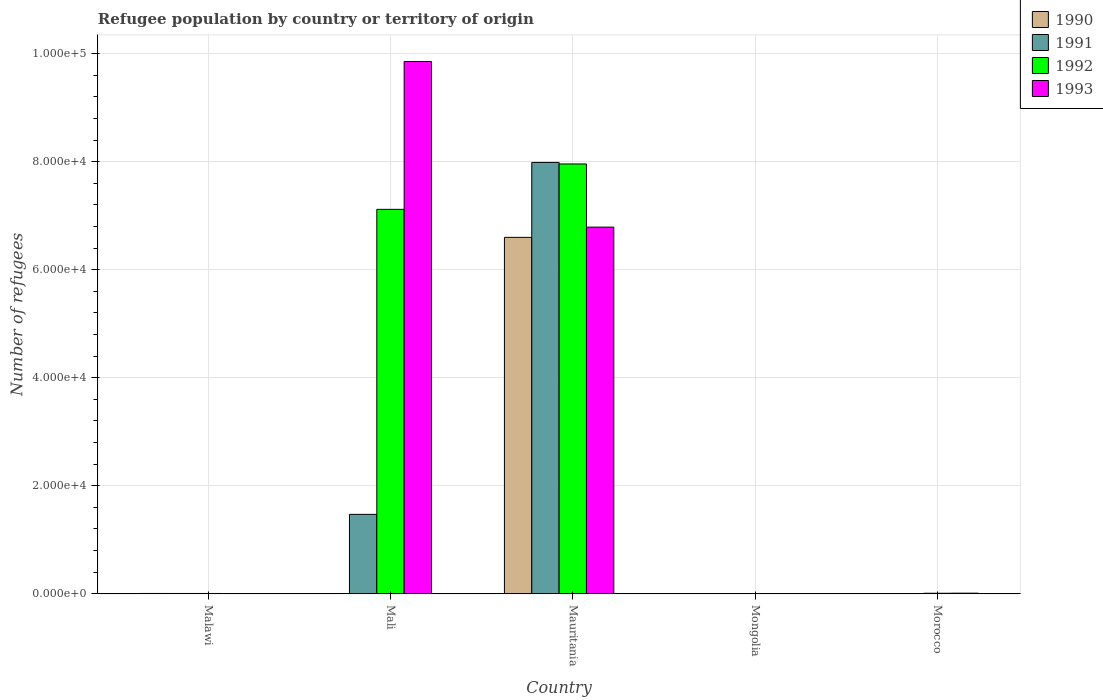How many different coloured bars are there?
Keep it short and to the point. 4. How many groups of bars are there?
Offer a terse response. 5. Are the number of bars per tick equal to the number of legend labels?
Ensure brevity in your answer.  Yes. How many bars are there on the 5th tick from the left?
Your response must be concise. 4. How many bars are there on the 1st tick from the right?
Your answer should be compact. 4. What is the label of the 2nd group of bars from the left?
Offer a terse response. Mali. What is the number of refugees in 1993 in Mongolia?
Ensure brevity in your answer.  1. Across all countries, what is the maximum number of refugees in 1992?
Provide a short and direct response. 7.96e+04. In which country was the number of refugees in 1990 maximum?
Give a very brief answer. Mauritania. In which country was the number of refugees in 1993 minimum?
Give a very brief answer. Mongolia. What is the total number of refugees in 1993 in the graph?
Provide a succinct answer. 1.67e+05. What is the difference between the number of refugees in 1992 in Malawi and that in Mali?
Keep it short and to the point. -7.11e+04. What is the difference between the number of refugees in 1992 in Mongolia and the number of refugees in 1993 in Malawi?
Offer a very short reply. -43. What is the average number of refugees in 1991 per country?
Ensure brevity in your answer.  1.89e+04. In how many countries, is the number of refugees in 1990 greater than 60000?
Your response must be concise. 1. What is the ratio of the number of refugees in 1990 in Malawi to that in Morocco?
Ensure brevity in your answer.  3.53. Is the number of refugees in 1991 in Mauritania less than that in Morocco?
Ensure brevity in your answer.  No. What is the difference between the highest and the second highest number of refugees in 1990?
Provide a succinct answer. -38. What is the difference between the highest and the lowest number of refugees in 1993?
Your response must be concise. 9.86e+04. Is the sum of the number of refugees in 1990 in Malawi and Morocco greater than the maximum number of refugees in 1992 across all countries?
Your answer should be compact. No. What does the 3rd bar from the right in Mongolia represents?
Keep it short and to the point. 1991. Is it the case that in every country, the sum of the number of refugees in 1993 and number of refugees in 1990 is greater than the number of refugees in 1991?
Offer a terse response. Yes. Are all the bars in the graph horizontal?
Provide a short and direct response. No. How many countries are there in the graph?
Your response must be concise. 5. Are the values on the major ticks of Y-axis written in scientific E-notation?
Give a very brief answer. Yes. Does the graph contain any zero values?
Provide a short and direct response. No. Does the graph contain grids?
Your answer should be very brief. Yes. How many legend labels are there?
Provide a short and direct response. 4. What is the title of the graph?
Your answer should be compact. Refugee population by country or territory of origin. What is the label or title of the Y-axis?
Your answer should be very brief. Number of refugees. What is the Number of refugees in 1990 in Malawi?
Your answer should be compact. 53. What is the Number of refugees of 1993 in Malawi?
Provide a short and direct response. 44. What is the Number of refugees in 1991 in Mali?
Ensure brevity in your answer.  1.47e+04. What is the Number of refugees in 1992 in Mali?
Offer a terse response. 7.12e+04. What is the Number of refugees in 1993 in Mali?
Your answer should be very brief. 9.86e+04. What is the Number of refugees of 1990 in Mauritania?
Your answer should be very brief. 6.60e+04. What is the Number of refugees in 1991 in Mauritania?
Make the answer very short. 7.99e+04. What is the Number of refugees of 1992 in Mauritania?
Give a very brief answer. 7.96e+04. What is the Number of refugees in 1993 in Mauritania?
Ensure brevity in your answer.  6.79e+04. What is the Number of refugees in 1990 in Mongolia?
Your answer should be very brief. 1. What is the Number of refugees in 1991 in Mongolia?
Your answer should be very brief. 1. What is the Number of refugees of 1992 in Mongolia?
Offer a very short reply. 1. What is the Number of refugees in 1993 in Mongolia?
Offer a terse response. 1. What is the Number of refugees in 1990 in Morocco?
Your answer should be very brief. 15. What is the Number of refugees of 1991 in Morocco?
Provide a short and direct response. 44. What is the Number of refugees in 1992 in Morocco?
Keep it short and to the point. 91. What is the Number of refugees in 1993 in Morocco?
Your response must be concise. 105. Across all countries, what is the maximum Number of refugees in 1990?
Your response must be concise. 6.60e+04. Across all countries, what is the maximum Number of refugees of 1991?
Offer a terse response. 7.99e+04. Across all countries, what is the maximum Number of refugees in 1992?
Your answer should be compact. 7.96e+04. Across all countries, what is the maximum Number of refugees of 1993?
Ensure brevity in your answer.  9.86e+04. Across all countries, what is the minimum Number of refugees of 1990?
Offer a very short reply. 1. Across all countries, what is the minimum Number of refugees of 1991?
Make the answer very short. 1. What is the total Number of refugees of 1990 in the graph?
Offer a very short reply. 6.61e+04. What is the total Number of refugees of 1991 in the graph?
Make the answer very short. 9.47e+04. What is the total Number of refugees of 1992 in the graph?
Your response must be concise. 1.51e+05. What is the total Number of refugees of 1993 in the graph?
Keep it short and to the point. 1.67e+05. What is the difference between the Number of refugees in 1990 in Malawi and that in Mali?
Your answer should be very brief. 52. What is the difference between the Number of refugees in 1991 in Malawi and that in Mali?
Your answer should be compact. -1.47e+04. What is the difference between the Number of refugees in 1992 in Malawi and that in Mali?
Ensure brevity in your answer.  -7.11e+04. What is the difference between the Number of refugees in 1993 in Malawi and that in Mali?
Offer a very short reply. -9.85e+04. What is the difference between the Number of refugees in 1990 in Malawi and that in Mauritania?
Provide a short and direct response. -6.59e+04. What is the difference between the Number of refugees in 1991 in Malawi and that in Mauritania?
Offer a very short reply. -7.98e+04. What is the difference between the Number of refugees of 1992 in Malawi and that in Mauritania?
Your answer should be compact. -7.95e+04. What is the difference between the Number of refugees of 1993 in Malawi and that in Mauritania?
Your response must be concise. -6.78e+04. What is the difference between the Number of refugees of 1990 in Malawi and that in Mongolia?
Provide a succinct answer. 52. What is the difference between the Number of refugees in 1990 in Malawi and that in Morocco?
Ensure brevity in your answer.  38. What is the difference between the Number of refugees in 1992 in Malawi and that in Morocco?
Make the answer very short. -41. What is the difference between the Number of refugees of 1993 in Malawi and that in Morocco?
Your answer should be very brief. -61. What is the difference between the Number of refugees of 1990 in Mali and that in Mauritania?
Your answer should be compact. -6.60e+04. What is the difference between the Number of refugees in 1991 in Mali and that in Mauritania?
Make the answer very short. -6.52e+04. What is the difference between the Number of refugees in 1992 in Mali and that in Mauritania?
Ensure brevity in your answer.  -8405. What is the difference between the Number of refugees of 1993 in Mali and that in Mauritania?
Keep it short and to the point. 3.07e+04. What is the difference between the Number of refugees in 1991 in Mali and that in Mongolia?
Your answer should be very brief. 1.47e+04. What is the difference between the Number of refugees in 1992 in Mali and that in Mongolia?
Offer a very short reply. 7.12e+04. What is the difference between the Number of refugees in 1993 in Mali and that in Mongolia?
Offer a very short reply. 9.86e+04. What is the difference between the Number of refugees in 1991 in Mali and that in Morocco?
Offer a very short reply. 1.47e+04. What is the difference between the Number of refugees of 1992 in Mali and that in Morocco?
Provide a succinct answer. 7.11e+04. What is the difference between the Number of refugees in 1993 in Mali and that in Morocco?
Keep it short and to the point. 9.85e+04. What is the difference between the Number of refugees of 1990 in Mauritania and that in Mongolia?
Offer a very short reply. 6.60e+04. What is the difference between the Number of refugees in 1991 in Mauritania and that in Mongolia?
Make the answer very short. 7.99e+04. What is the difference between the Number of refugees of 1992 in Mauritania and that in Mongolia?
Give a very brief answer. 7.96e+04. What is the difference between the Number of refugees of 1993 in Mauritania and that in Mongolia?
Offer a very short reply. 6.79e+04. What is the difference between the Number of refugees in 1990 in Mauritania and that in Morocco?
Your answer should be very brief. 6.60e+04. What is the difference between the Number of refugees of 1991 in Mauritania and that in Morocco?
Provide a succinct answer. 7.98e+04. What is the difference between the Number of refugees in 1992 in Mauritania and that in Morocco?
Offer a very short reply. 7.95e+04. What is the difference between the Number of refugees in 1993 in Mauritania and that in Morocco?
Your response must be concise. 6.78e+04. What is the difference between the Number of refugees of 1990 in Mongolia and that in Morocco?
Your answer should be compact. -14. What is the difference between the Number of refugees in 1991 in Mongolia and that in Morocco?
Give a very brief answer. -43. What is the difference between the Number of refugees in 1992 in Mongolia and that in Morocco?
Provide a succinct answer. -90. What is the difference between the Number of refugees of 1993 in Mongolia and that in Morocco?
Your response must be concise. -104. What is the difference between the Number of refugees of 1990 in Malawi and the Number of refugees of 1991 in Mali?
Give a very brief answer. -1.47e+04. What is the difference between the Number of refugees of 1990 in Malawi and the Number of refugees of 1992 in Mali?
Offer a very short reply. -7.11e+04. What is the difference between the Number of refugees in 1990 in Malawi and the Number of refugees in 1993 in Mali?
Give a very brief answer. -9.85e+04. What is the difference between the Number of refugees of 1991 in Malawi and the Number of refugees of 1992 in Mali?
Your response must be concise. -7.11e+04. What is the difference between the Number of refugees of 1991 in Malawi and the Number of refugees of 1993 in Mali?
Make the answer very short. -9.85e+04. What is the difference between the Number of refugees in 1992 in Malawi and the Number of refugees in 1993 in Mali?
Offer a terse response. -9.85e+04. What is the difference between the Number of refugees in 1990 in Malawi and the Number of refugees in 1991 in Mauritania?
Make the answer very short. -7.98e+04. What is the difference between the Number of refugees in 1990 in Malawi and the Number of refugees in 1992 in Mauritania?
Make the answer very short. -7.95e+04. What is the difference between the Number of refugees in 1990 in Malawi and the Number of refugees in 1993 in Mauritania?
Make the answer very short. -6.78e+04. What is the difference between the Number of refugees of 1991 in Malawi and the Number of refugees of 1992 in Mauritania?
Ensure brevity in your answer.  -7.95e+04. What is the difference between the Number of refugees in 1991 in Malawi and the Number of refugees in 1993 in Mauritania?
Provide a short and direct response. -6.78e+04. What is the difference between the Number of refugees of 1992 in Malawi and the Number of refugees of 1993 in Mauritania?
Your answer should be compact. -6.78e+04. What is the difference between the Number of refugees of 1990 in Malawi and the Number of refugees of 1991 in Mongolia?
Provide a succinct answer. 52. What is the difference between the Number of refugees in 1990 in Malawi and the Number of refugees in 1992 in Mongolia?
Your answer should be very brief. 52. What is the difference between the Number of refugees in 1990 in Malawi and the Number of refugees in 1993 in Mongolia?
Your answer should be compact. 52. What is the difference between the Number of refugees of 1991 in Malawi and the Number of refugees of 1993 in Mongolia?
Provide a short and direct response. 49. What is the difference between the Number of refugees in 1990 in Malawi and the Number of refugees in 1992 in Morocco?
Make the answer very short. -38. What is the difference between the Number of refugees in 1990 in Malawi and the Number of refugees in 1993 in Morocco?
Your response must be concise. -52. What is the difference between the Number of refugees in 1991 in Malawi and the Number of refugees in 1992 in Morocco?
Provide a short and direct response. -41. What is the difference between the Number of refugees of 1991 in Malawi and the Number of refugees of 1993 in Morocco?
Ensure brevity in your answer.  -55. What is the difference between the Number of refugees of 1992 in Malawi and the Number of refugees of 1993 in Morocco?
Your response must be concise. -55. What is the difference between the Number of refugees in 1990 in Mali and the Number of refugees in 1991 in Mauritania?
Ensure brevity in your answer.  -7.99e+04. What is the difference between the Number of refugees of 1990 in Mali and the Number of refugees of 1992 in Mauritania?
Offer a terse response. -7.96e+04. What is the difference between the Number of refugees of 1990 in Mali and the Number of refugees of 1993 in Mauritania?
Your answer should be compact. -6.79e+04. What is the difference between the Number of refugees in 1991 in Mali and the Number of refugees in 1992 in Mauritania?
Your response must be concise. -6.49e+04. What is the difference between the Number of refugees in 1991 in Mali and the Number of refugees in 1993 in Mauritania?
Your answer should be very brief. -5.32e+04. What is the difference between the Number of refugees of 1992 in Mali and the Number of refugees of 1993 in Mauritania?
Provide a short and direct response. 3295. What is the difference between the Number of refugees in 1990 in Mali and the Number of refugees in 1993 in Mongolia?
Offer a terse response. 0. What is the difference between the Number of refugees in 1991 in Mali and the Number of refugees in 1992 in Mongolia?
Offer a terse response. 1.47e+04. What is the difference between the Number of refugees of 1991 in Mali and the Number of refugees of 1993 in Mongolia?
Your response must be concise. 1.47e+04. What is the difference between the Number of refugees of 1992 in Mali and the Number of refugees of 1993 in Mongolia?
Provide a short and direct response. 7.12e+04. What is the difference between the Number of refugees in 1990 in Mali and the Number of refugees in 1991 in Morocco?
Provide a succinct answer. -43. What is the difference between the Number of refugees of 1990 in Mali and the Number of refugees of 1992 in Morocco?
Ensure brevity in your answer.  -90. What is the difference between the Number of refugees of 1990 in Mali and the Number of refugees of 1993 in Morocco?
Give a very brief answer. -104. What is the difference between the Number of refugees in 1991 in Mali and the Number of refugees in 1992 in Morocco?
Offer a terse response. 1.46e+04. What is the difference between the Number of refugees of 1991 in Mali and the Number of refugees of 1993 in Morocco?
Your answer should be very brief. 1.46e+04. What is the difference between the Number of refugees in 1992 in Mali and the Number of refugees in 1993 in Morocco?
Your answer should be very brief. 7.11e+04. What is the difference between the Number of refugees of 1990 in Mauritania and the Number of refugees of 1991 in Mongolia?
Offer a very short reply. 6.60e+04. What is the difference between the Number of refugees of 1990 in Mauritania and the Number of refugees of 1992 in Mongolia?
Provide a short and direct response. 6.60e+04. What is the difference between the Number of refugees of 1990 in Mauritania and the Number of refugees of 1993 in Mongolia?
Provide a short and direct response. 6.60e+04. What is the difference between the Number of refugees in 1991 in Mauritania and the Number of refugees in 1992 in Mongolia?
Provide a short and direct response. 7.99e+04. What is the difference between the Number of refugees in 1991 in Mauritania and the Number of refugees in 1993 in Mongolia?
Ensure brevity in your answer.  7.99e+04. What is the difference between the Number of refugees in 1992 in Mauritania and the Number of refugees in 1993 in Mongolia?
Provide a succinct answer. 7.96e+04. What is the difference between the Number of refugees of 1990 in Mauritania and the Number of refugees of 1991 in Morocco?
Ensure brevity in your answer.  6.60e+04. What is the difference between the Number of refugees of 1990 in Mauritania and the Number of refugees of 1992 in Morocco?
Your response must be concise. 6.59e+04. What is the difference between the Number of refugees of 1990 in Mauritania and the Number of refugees of 1993 in Morocco?
Provide a short and direct response. 6.59e+04. What is the difference between the Number of refugees of 1991 in Mauritania and the Number of refugees of 1992 in Morocco?
Offer a very short reply. 7.98e+04. What is the difference between the Number of refugees of 1991 in Mauritania and the Number of refugees of 1993 in Morocco?
Provide a succinct answer. 7.98e+04. What is the difference between the Number of refugees in 1992 in Mauritania and the Number of refugees in 1993 in Morocco?
Give a very brief answer. 7.95e+04. What is the difference between the Number of refugees in 1990 in Mongolia and the Number of refugees in 1991 in Morocco?
Make the answer very short. -43. What is the difference between the Number of refugees of 1990 in Mongolia and the Number of refugees of 1992 in Morocco?
Offer a very short reply. -90. What is the difference between the Number of refugees of 1990 in Mongolia and the Number of refugees of 1993 in Morocco?
Make the answer very short. -104. What is the difference between the Number of refugees of 1991 in Mongolia and the Number of refugees of 1992 in Morocco?
Offer a very short reply. -90. What is the difference between the Number of refugees of 1991 in Mongolia and the Number of refugees of 1993 in Morocco?
Give a very brief answer. -104. What is the difference between the Number of refugees of 1992 in Mongolia and the Number of refugees of 1993 in Morocco?
Your response must be concise. -104. What is the average Number of refugees of 1990 per country?
Ensure brevity in your answer.  1.32e+04. What is the average Number of refugees in 1991 per country?
Your answer should be compact. 1.89e+04. What is the average Number of refugees of 1992 per country?
Your response must be concise. 3.02e+04. What is the average Number of refugees in 1993 per country?
Make the answer very short. 3.33e+04. What is the difference between the Number of refugees in 1990 and Number of refugees in 1991 in Malawi?
Make the answer very short. 3. What is the difference between the Number of refugees in 1990 and Number of refugees in 1993 in Malawi?
Offer a very short reply. 9. What is the difference between the Number of refugees in 1992 and Number of refugees in 1993 in Malawi?
Provide a short and direct response. 6. What is the difference between the Number of refugees in 1990 and Number of refugees in 1991 in Mali?
Make the answer very short. -1.47e+04. What is the difference between the Number of refugees in 1990 and Number of refugees in 1992 in Mali?
Offer a very short reply. -7.12e+04. What is the difference between the Number of refugees in 1990 and Number of refugees in 1993 in Mali?
Provide a short and direct response. -9.86e+04. What is the difference between the Number of refugees of 1991 and Number of refugees of 1992 in Mali?
Offer a very short reply. -5.65e+04. What is the difference between the Number of refugees in 1991 and Number of refugees in 1993 in Mali?
Provide a succinct answer. -8.39e+04. What is the difference between the Number of refugees in 1992 and Number of refugees in 1993 in Mali?
Offer a terse response. -2.74e+04. What is the difference between the Number of refugees in 1990 and Number of refugees in 1991 in Mauritania?
Make the answer very short. -1.39e+04. What is the difference between the Number of refugees in 1990 and Number of refugees in 1992 in Mauritania?
Offer a terse response. -1.36e+04. What is the difference between the Number of refugees in 1990 and Number of refugees in 1993 in Mauritania?
Your answer should be compact. -1895. What is the difference between the Number of refugees of 1991 and Number of refugees of 1992 in Mauritania?
Offer a very short reply. 287. What is the difference between the Number of refugees in 1991 and Number of refugees in 1993 in Mauritania?
Give a very brief answer. 1.20e+04. What is the difference between the Number of refugees in 1992 and Number of refugees in 1993 in Mauritania?
Offer a very short reply. 1.17e+04. What is the difference between the Number of refugees of 1990 and Number of refugees of 1991 in Mongolia?
Provide a succinct answer. 0. What is the difference between the Number of refugees of 1991 and Number of refugees of 1993 in Mongolia?
Your response must be concise. 0. What is the difference between the Number of refugees in 1992 and Number of refugees in 1993 in Mongolia?
Provide a succinct answer. 0. What is the difference between the Number of refugees of 1990 and Number of refugees of 1991 in Morocco?
Provide a short and direct response. -29. What is the difference between the Number of refugees in 1990 and Number of refugees in 1992 in Morocco?
Keep it short and to the point. -76. What is the difference between the Number of refugees of 1990 and Number of refugees of 1993 in Morocco?
Offer a terse response. -90. What is the difference between the Number of refugees of 1991 and Number of refugees of 1992 in Morocco?
Provide a succinct answer. -47. What is the difference between the Number of refugees in 1991 and Number of refugees in 1993 in Morocco?
Give a very brief answer. -61. What is the difference between the Number of refugees of 1992 and Number of refugees of 1993 in Morocco?
Your answer should be very brief. -14. What is the ratio of the Number of refugees in 1990 in Malawi to that in Mali?
Your answer should be compact. 53. What is the ratio of the Number of refugees of 1991 in Malawi to that in Mali?
Provide a succinct answer. 0. What is the ratio of the Number of refugees in 1992 in Malawi to that in Mali?
Offer a terse response. 0. What is the ratio of the Number of refugees in 1993 in Malawi to that in Mali?
Provide a short and direct response. 0. What is the ratio of the Number of refugees of 1990 in Malawi to that in Mauritania?
Provide a short and direct response. 0. What is the ratio of the Number of refugees of 1991 in Malawi to that in Mauritania?
Provide a short and direct response. 0. What is the ratio of the Number of refugees of 1992 in Malawi to that in Mauritania?
Your answer should be very brief. 0. What is the ratio of the Number of refugees of 1993 in Malawi to that in Mauritania?
Offer a terse response. 0. What is the ratio of the Number of refugees of 1991 in Malawi to that in Mongolia?
Your response must be concise. 50. What is the ratio of the Number of refugees of 1990 in Malawi to that in Morocco?
Offer a very short reply. 3.53. What is the ratio of the Number of refugees of 1991 in Malawi to that in Morocco?
Ensure brevity in your answer.  1.14. What is the ratio of the Number of refugees in 1992 in Malawi to that in Morocco?
Your response must be concise. 0.55. What is the ratio of the Number of refugees of 1993 in Malawi to that in Morocco?
Your answer should be very brief. 0.42. What is the ratio of the Number of refugees in 1990 in Mali to that in Mauritania?
Make the answer very short. 0. What is the ratio of the Number of refugees of 1991 in Mali to that in Mauritania?
Give a very brief answer. 0.18. What is the ratio of the Number of refugees of 1992 in Mali to that in Mauritania?
Provide a short and direct response. 0.89. What is the ratio of the Number of refugees of 1993 in Mali to that in Mauritania?
Your answer should be compact. 1.45. What is the ratio of the Number of refugees in 1991 in Mali to that in Mongolia?
Provide a succinct answer. 1.47e+04. What is the ratio of the Number of refugees in 1992 in Mali to that in Mongolia?
Your answer should be compact. 7.12e+04. What is the ratio of the Number of refugees of 1993 in Mali to that in Mongolia?
Ensure brevity in your answer.  9.86e+04. What is the ratio of the Number of refugees of 1990 in Mali to that in Morocco?
Give a very brief answer. 0.07. What is the ratio of the Number of refugees in 1991 in Mali to that in Morocco?
Offer a very short reply. 334.18. What is the ratio of the Number of refugees of 1992 in Mali to that in Morocco?
Your answer should be very brief. 782.3. What is the ratio of the Number of refugees in 1993 in Mali to that in Morocco?
Keep it short and to the point. 938.78. What is the ratio of the Number of refugees of 1990 in Mauritania to that in Mongolia?
Provide a succinct answer. 6.60e+04. What is the ratio of the Number of refugees in 1991 in Mauritania to that in Mongolia?
Your answer should be compact. 7.99e+04. What is the ratio of the Number of refugees of 1992 in Mauritania to that in Mongolia?
Keep it short and to the point. 7.96e+04. What is the ratio of the Number of refugees in 1993 in Mauritania to that in Mongolia?
Provide a succinct answer. 6.79e+04. What is the ratio of the Number of refugees of 1990 in Mauritania to that in Morocco?
Your answer should be very brief. 4399.93. What is the ratio of the Number of refugees of 1991 in Mauritania to that in Morocco?
Give a very brief answer. 1815.48. What is the ratio of the Number of refugees of 1992 in Mauritania to that in Morocco?
Provide a short and direct response. 874.66. What is the ratio of the Number of refugees of 1993 in Mauritania to that in Morocco?
Offer a very short reply. 646.61. What is the ratio of the Number of refugees of 1990 in Mongolia to that in Morocco?
Keep it short and to the point. 0.07. What is the ratio of the Number of refugees in 1991 in Mongolia to that in Morocco?
Offer a terse response. 0.02. What is the ratio of the Number of refugees of 1992 in Mongolia to that in Morocco?
Your response must be concise. 0.01. What is the ratio of the Number of refugees in 1993 in Mongolia to that in Morocco?
Make the answer very short. 0.01. What is the difference between the highest and the second highest Number of refugees of 1990?
Offer a very short reply. 6.59e+04. What is the difference between the highest and the second highest Number of refugees in 1991?
Your answer should be compact. 6.52e+04. What is the difference between the highest and the second highest Number of refugees of 1992?
Offer a very short reply. 8405. What is the difference between the highest and the second highest Number of refugees of 1993?
Your response must be concise. 3.07e+04. What is the difference between the highest and the lowest Number of refugees of 1990?
Provide a succinct answer. 6.60e+04. What is the difference between the highest and the lowest Number of refugees of 1991?
Your response must be concise. 7.99e+04. What is the difference between the highest and the lowest Number of refugees of 1992?
Your answer should be very brief. 7.96e+04. What is the difference between the highest and the lowest Number of refugees in 1993?
Give a very brief answer. 9.86e+04. 